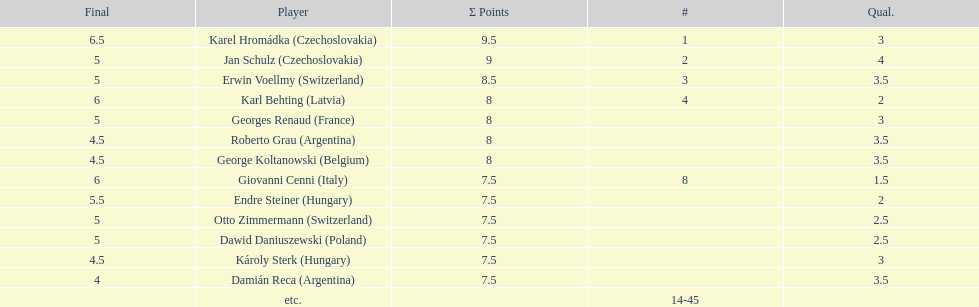The most points were scored by which player? Karel Hromádka. 